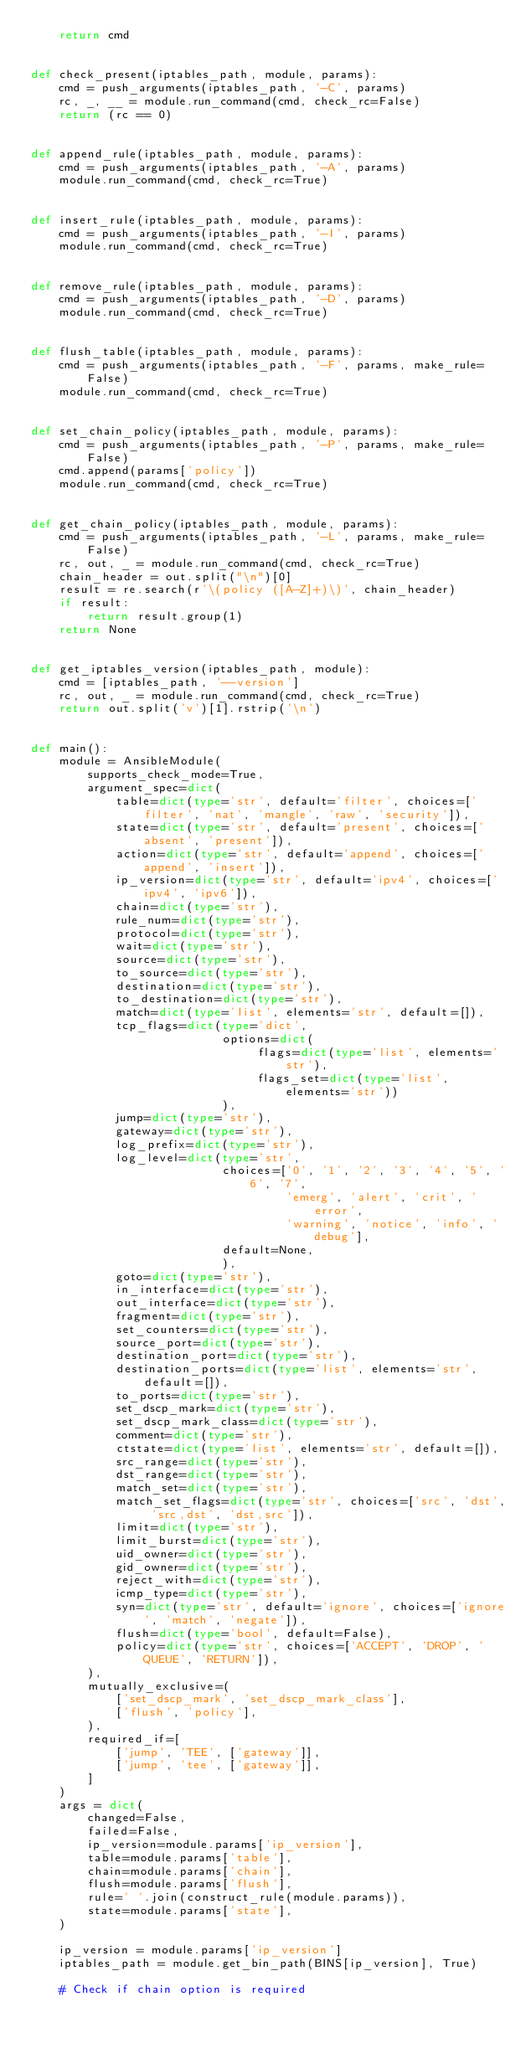<code> <loc_0><loc_0><loc_500><loc_500><_Python_>    return cmd


def check_present(iptables_path, module, params):
    cmd = push_arguments(iptables_path, '-C', params)
    rc, _, __ = module.run_command(cmd, check_rc=False)
    return (rc == 0)


def append_rule(iptables_path, module, params):
    cmd = push_arguments(iptables_path, '-A', params)
    module.run_command(cmd, check_rc=True)


def insert_rule(iptables_path, module, params):
    cmd = push_arguments(iptables_path, '-I', params)
    module.run_command(cmd, check_rc=True)


def remove_rule(iptables_path, module, params):
    cmd = push_arguments(iptables_path, '-D', params)
    module.run_command(cmd, check_rc=True)


def flush_table(iptables_path, module, params):
    cmd = push_arguments(iptables_path, '-F', params, make_rule=False)
    module.run_command(cmd, check_rc=True)


def set_chain_policy(iptables_path, module, params):
    cmd = push_arguments(iptables_path, '-P', params, make_rule=False)
    cmd.append(params['policy'])
    module.run_command(cmd, check_rc=True)


def get_chain_policy(iptables_path, module, params):
    cmd = push_arguments(iptables_path, '-L', params, make_rule=False)
    rc, out, _ = module.run_command(cmd, check_rc=True)
    chain_header = out.split("\n")[0]
    result = re.search(r'\(policy ([A-Z]+)\)', chain_header)
    if result:
        return result.group(1)
    return None


def get_iptables_version(iptables_path, module):
    cmd = [iptables_path, '--version']
    rc, out, _ = module.run_command(cmd, check_rc=True)
    return out.split('v')[1].rstrip('\n')


def main():
    module = AnsibleModule(
        supports_check_mode=True,
        argument_spec=dict(
            table=dict(type='str', default='filter', choices=['filter', 'nat', 'mangle', 'raw', 'security']),
            state=dict(type='str', default='present', choices=['absent', 'present']),
            action=dict(type='str', default='append', choices=['append', 'insert']),
            ip_version=dict(type='str', default='ipv4', choices=['ipv4', 'ipv6']),
            chain=dict(type='str'),
            rule_num=dict(type='str'),
            protocol=dict(type='str'),
            wait=dict(type='str'),
            source=dict(type='str'),
            to_source=dict(type='str'),
            destination=dict(type='str'),
            to_destination=dict(type='str'),
            match=dict(type='list', elements='str', default=[]),
            tcp_flags=dict(type='dict',
                           options=dict(
                                flags=dict(type='list', elements='str'),
                                flags_set=dict(type='list', elements='str'))
                           ),
            jump=dict(type='str'),
            gateway=dict(type='str'),
            log_prefix=dict(type='str'),
            log_level=dict(type='str',
                           choices=['0', '1', '2', '3', '4', '5', '6', '7',
                                    'emerg', 'alert', 'crit', 'error',
                                    'warning', 'notice', 'info', 'debug'],
                           default=None,
                           ),
            goto=dict(type='str'),
            in_interface=dict(type='str'),
            out_interface=dict(type='str'),
            fragment=dict(type='str'),
            set_counters=dict(type='str'),
            source_port=dict(type='str'),
            destination_port=dict(type='str'),
            destination_ports=dict(type='list', elements='str', default=[]),
            to_ports=dict(type='str'),
            set_dscp_mark=dict(type='str'),
            set_dscp_mark_class=dict(type='str'),
            comment=dict(type='str'),
            ctstate=dict(type='list', elements='str', default=[]),
            src_range=dict(type='str'),
            dst_range=dict(type='str'),
            match_set=dict(type='str'),
            match_set_flags=dict(type='str', choices=['src', 'dst', 'src,dst', 'dst,src']),
            limit=dict(type='str'),
            limit_burst=dict(type='str'),
            uid_owner=dict(type='str'),
            gid_owner=dict(type='str'),
            reject_with=dict(type='str'),
            icmp_type=dict(type='str'),
            syn=dict(type='str', default='ignore', choices=['ignore', 'match', 'negate']),
            flush=dict(type='bool', default=False),
            policy=dict(type='str', choices=['ACCEPT', 'DROP', 'QUEUE', 'RETURN']),
        ),
        mutually_exclusive=(
            ['set_dscp_mark', 'set_dscp_mark_class'],
            ['flush', 'policy'],
        ),
        required_if=[
            ['jump', 'TEE', ['gateway']],
            ['jump', 'tee', ['gateway']],
        ]
    )
    args = dict(
        changed=False,
        failed=False,
        ip_version=module.params['ip_version'],
        table=module.params['table'],
        chain=module.params['chain'],
        flush=module.params['flush'],
        rule=' '.join(construct_rule(module.params)),
        state=module.params['state'],
    )

    ip_version = module.params['ip_version']
    iptables_path = module.get_bin_path(BINS[ip_version], True)

    # Check if chain option is required</code> 